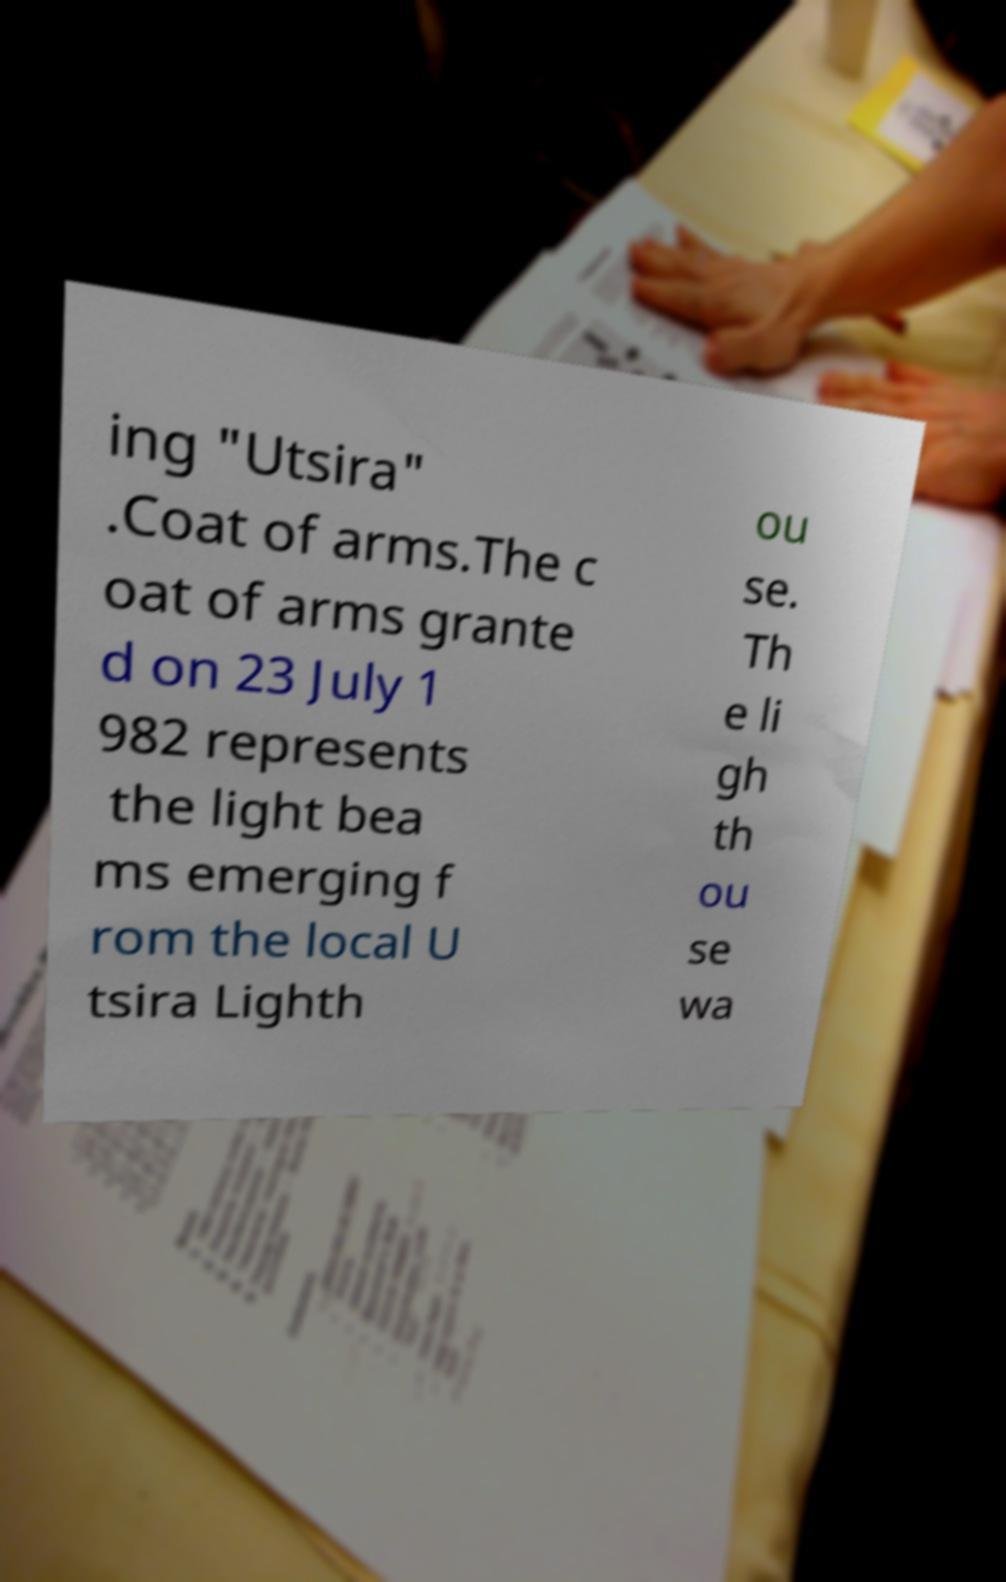What messages or text are displayed in this image? I need them in a readable, typed format. ing "Utsira" .Coat of arms.The c oat of arms grante d on 23 July 1 982 represents the light bea ms emerging f rom the local U tsira Lighth ou se. Th e li gh th ou se wa 